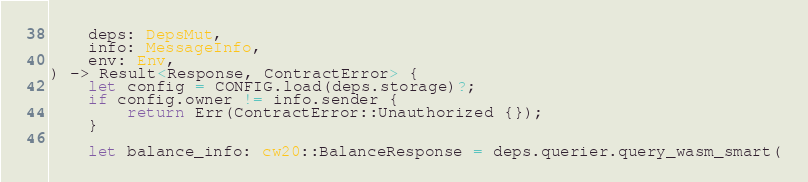<code> <loc_0><loc_0><loc_500><loc_500><_Rust_>    deps: DepsMut,
    info: MessageInfo,
    env: Env,
) -> Result<Response, ContractError> {
    let config = CONFIG.load(deps.storage)?;
    if config.owner != info.sender {
        return Err(ContractError::Unauthorized {});
    }

    let balance_info: cw20::BalanceResponse = deps.querier.query_wasm_smart(</code> 